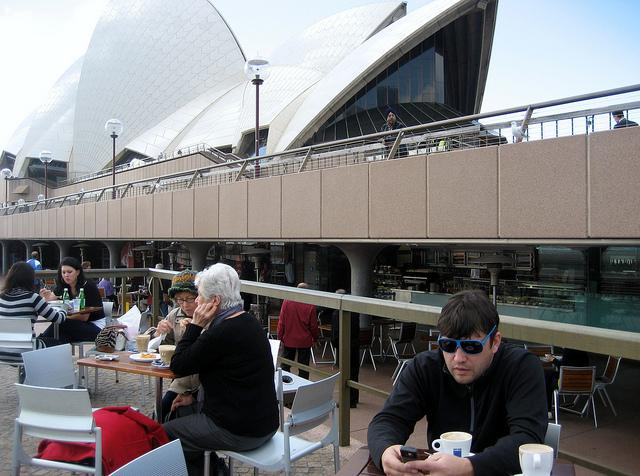What type of entertainment is commonly held in the building behind the people eating? Please explain your reasoning. opera. The opera house in australia is shown. 